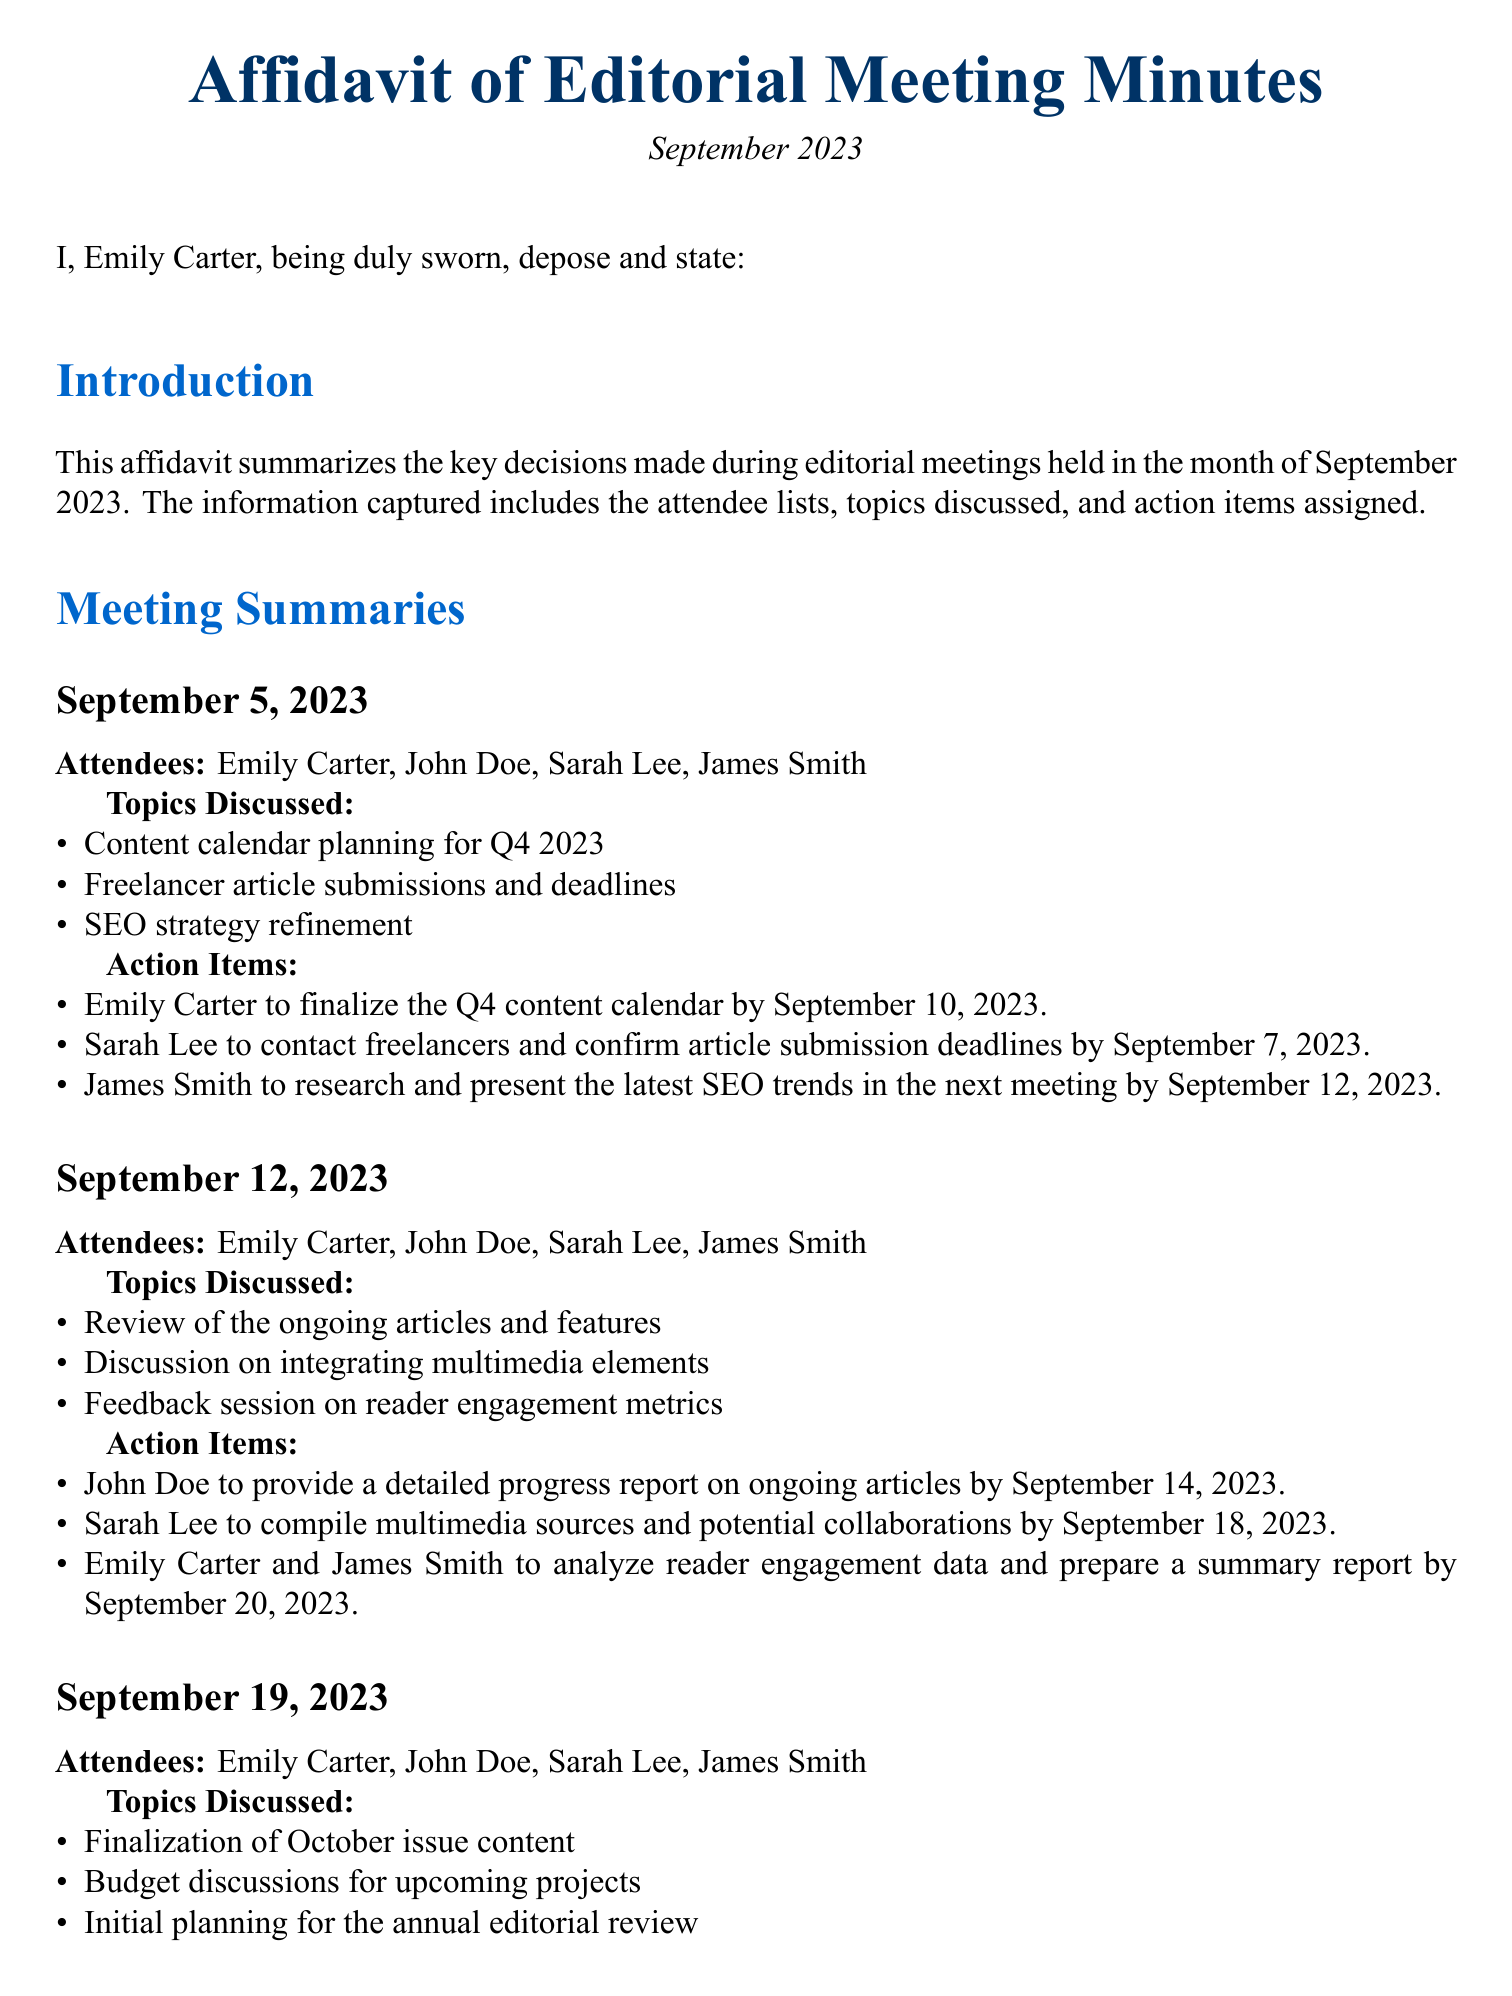What is the date of the affidavit? The date of the affidavit is stated at the beginning of the document, indicating when it was created and signed.
Answer: September 2023 Who is the managing editor who signed the affidavit? The managing editor who signed the affidavit is identified at the end of the document, confirming her role.
Answer: Emily Carter What is one of the action items assigned on September 5, 2023? The document lists specific action items assigned during each meeting, including due dates.
Answer: Finalize the Q4 content calendar How many meetings were held in September 2023? The document provides summaries of the meetings, indicating how many took place throughout the month.
Answer: Three What topic was discussed on September 12, 2023? Each meeting summary details specific topics discussed, showing the focus areas of that meeting.
Answer: Reader engagement metrics When was the final content for the October issue to be approved? The action items section includes deadlines for tasks, which shows when important decisions are due.
Answer: September 25, 2023 What was one task assigned to Sarah Lee in the September 12, 2023 meeting? The action items specify individual responsibilities assigned during the meeting.
Answer: Compile multimedia sources When was John Doe to provide a progress report? The document lists when each action item is due, which helps track accountability.
Answer: September 14, 2023 What is the primary purpose of this affidavit? The affidavit's introduction summarizes what information it contains about the editorial meetings.
Answer: Summarizes key decisions made during editorial meetings 